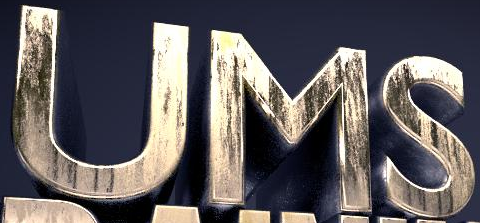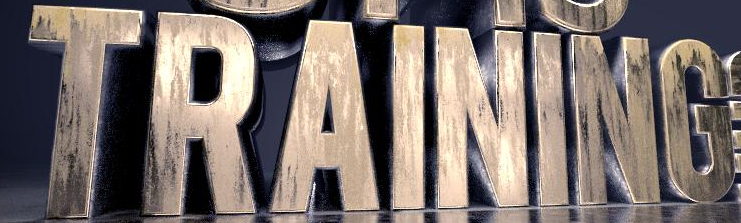Transcribe the words shown in these images in order, separated by a semicolon. UMS; TRAINING 